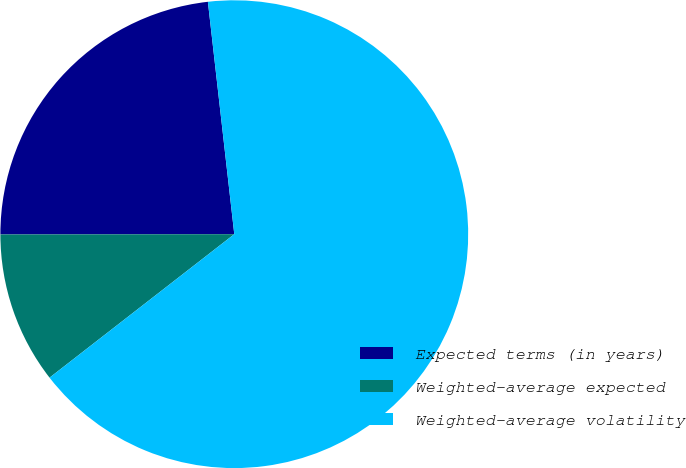<chart> <loc_0><loc_0><loc_500><loc_500><pie_chart><fcel>Expected terms (in years)<fcel>Weighted-average expected<fcel>Weighted-average volatility<nl><fcel>23.22%<fcel>10.49%<fcel>66.29%<nl></chart> 